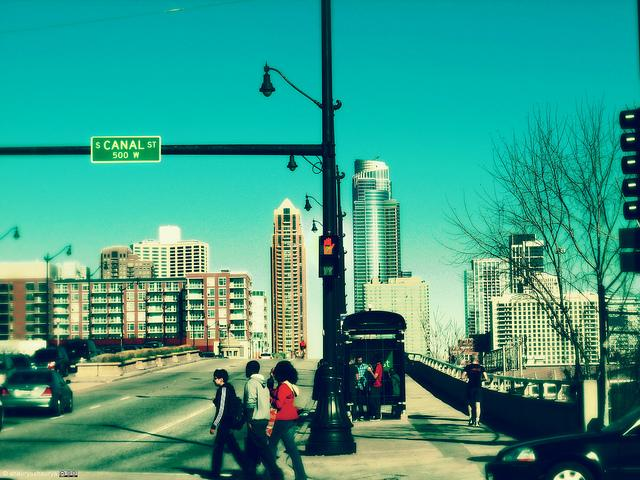What is the hand on the traffic light telling those facing it? Please explain your reasoning. stop. The hand is saying to stop and don't walk. 